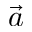Convert formula to latex. <formula><loc_0><loc_0><loc_500><loc_500>\vec { a }</formula> 